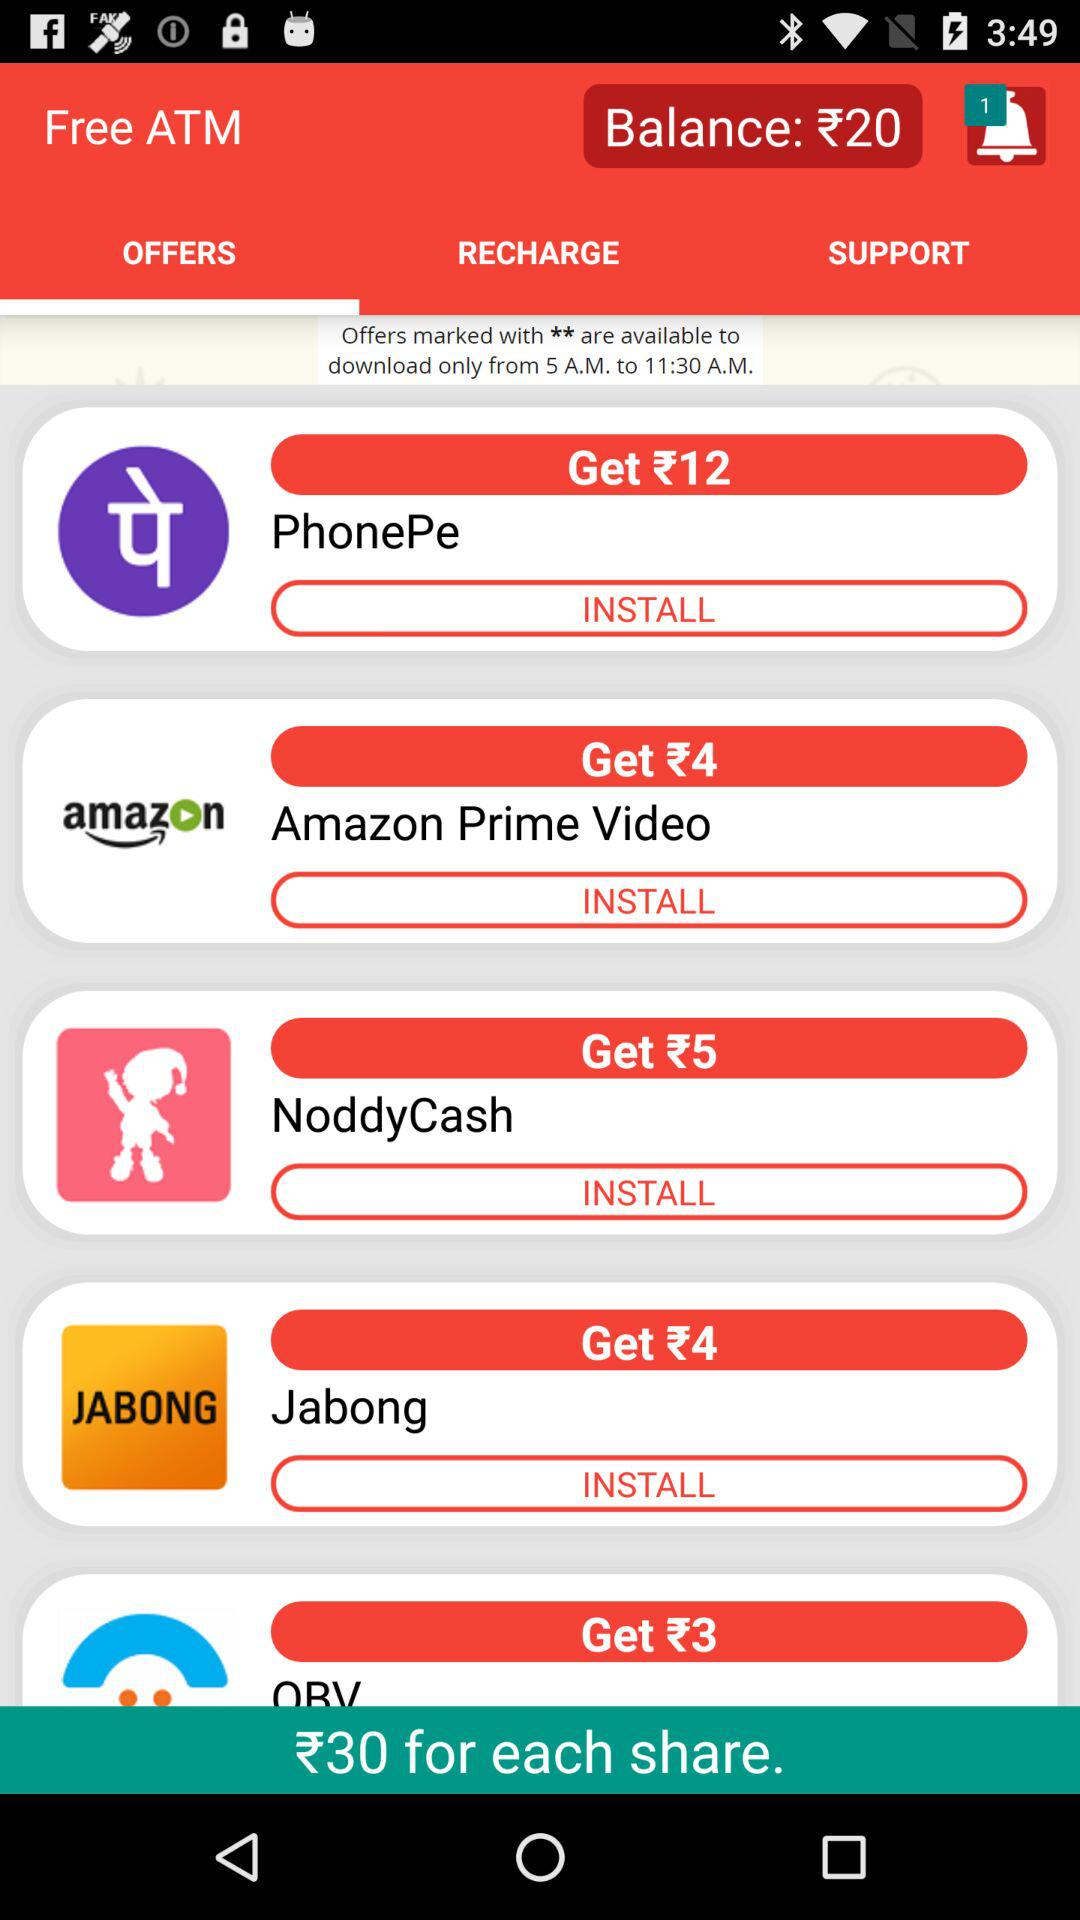How much shall we get for each share? You will get 30 rupees for each share. 